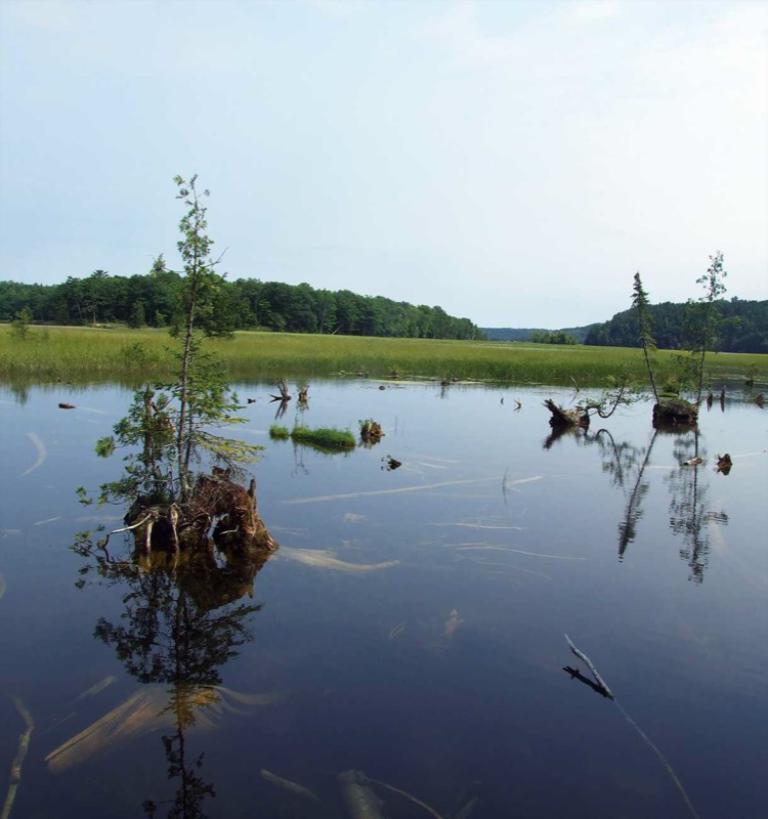How would you summarize this image in a sentence or two? This is an outside view. Here I can see few plants in the water. In the background, I can see the grass and many trees. At the top of the image I can see the sky. 